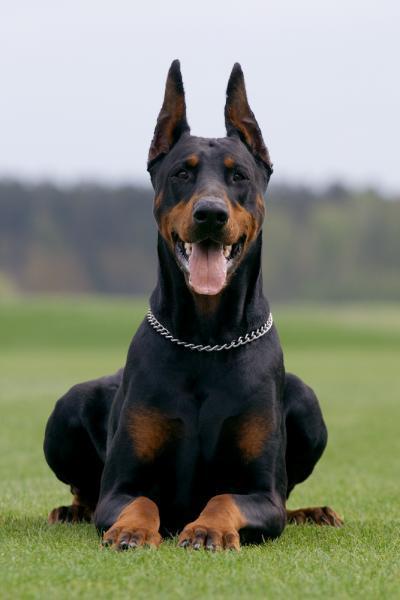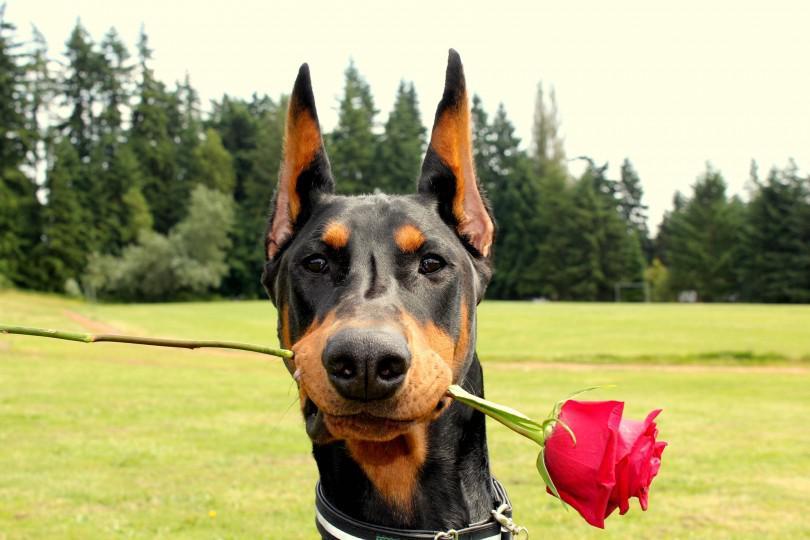The first image is the image on the left, the second image is the image on the right. Analyze the images presented: Is the assertion "A single dog in the grass is showing its tongue in the image on the left." valid? Answer yes or no. Yes. The first image is the image on the left, the second image is the image on the right. Assess this claim about the two images: "Each image contains one dog, and one of the dogs depicted wears a chain collar, while the other dog has something held in its mouth.". Correct or not? Answer yes or no. Yes. 